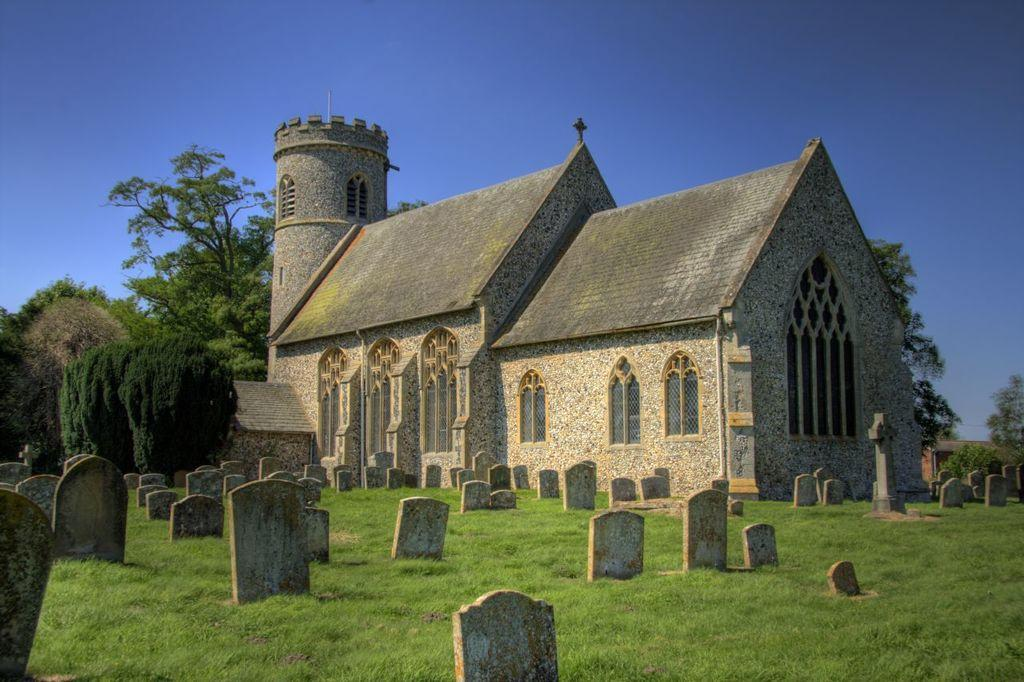What type of building is in the image? There is a brown color church in the image. What material is used for the roof of the church? The church has shed tiles. What is located in front of the church? There is a graveyard in front of the church. How are the graves marked in the graveyard? The graveyard has many stone and cross marks. What can be seen behind the church? There are trees visible behind the church. How many nails can be seen holding the ladybug to the tree in the image? There is no ladybug present in the image, and therefore no nails can be seen holding it to a tree. 